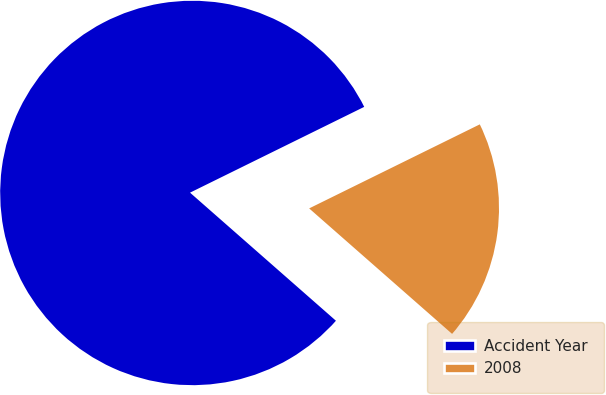Convert chart. <chart><loc_0><loc_0><loc_500><loc_500><pie_chart><fcel>Accident Year<fcel>2008<nl><fcel>81.25%<fcel>18.75%<nl></chart> 